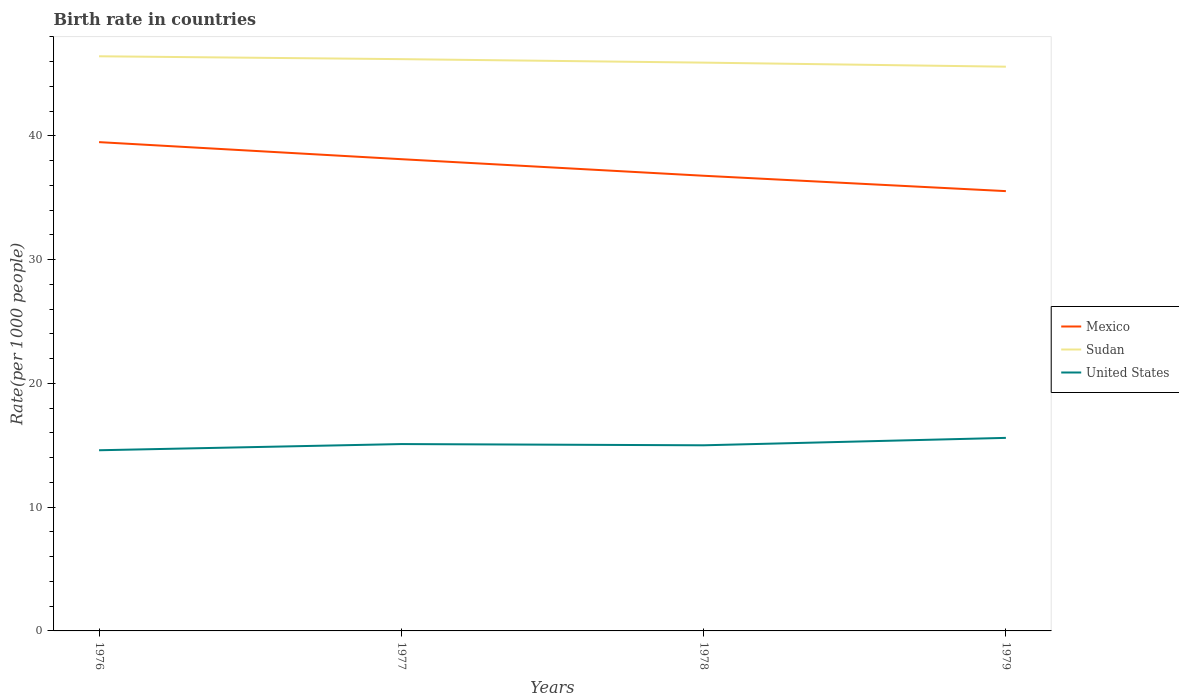In which year was the birth rate in Mexico maximum?
Offer a terse response. 1979. What is the difference between the highest and the second highest birth rate in Sudan?
Your response must be concise. 0.84. How many lines are there?
Provide a succinct answer. 3. How many years are there in the graph?
Offer a very short reply. 4. What is the difference between two consecutive major ticks on the Y-axis?
Offer a terse response. 10. Does the graph contain any zero values?
Offer a terse response. No. Where does the legend appear in the graph?
Keep it short and to the point. Center right. How are the legend labels stacked?
Provide a succinct answer. Vertical. What is the title of the graph?
Your answer should be very brief. Birth rate in countries. What is the label or title of the Y-axis?
Offer a very short reply. Rate(per 1000 people). What is the Rate(per 1000 people) in Mexico in 1976?
Keep it short and to the point. 39.5. What is the Rate(per 1000 people) in Sudan in 1976?
Your answer should be compact. 46.44. What is the Rate(per 1000 people) in United States in 1976?
Offer a very short reply. 14.6. What is the Rate(per 1000 people) of Mexico in 1977?
Offer a terse response. 38.12. What is the Rate(per 1000 people) in Sudan in 1977?
Ensure brevity in your answer.  46.2. What is the Rate(per 1000 people) in United States in 1977?
Your response must be concise. 15.1. What is the Rate(per 1000 people) of Mexico in 1978?
Provide a short and direct response. 36.78. What is the Rate(per 1000 people) of Sudan in 1978?
Provide a short and direct response. 45.92. What is the Rate(per 1000 people) in United States in 1978?
Provide a succinct answer. 15. What is the Rate(per 1000 people) in Mexico in 1979?
Offer a very short reply. 35.54. What is the Rate(per 1000 people) of Sudan in 1979?
Offer a very short reply. 45.6. Across all years, what is the maximum Rate(per 1000 people) of Mexico?
Provide a succinct answer. 39.5. Across all years, what is the maximum Rate(per 1000 people) of Sudan?
Your response must be concise. 46.44. Across all years, what is the maximum Rate(per 1000 people) of United States?
Provide a short and direct response. 15.6. Across all years, what is the minimum Rate(per 1000 people) of Mexico?
Ensure brevity in your answer.  35.54. Across all years, what is the minimum Rate(per 1000 people) of Sudan?
Provide a short and direct response. 45.6. Across all years, what is the minimum Rate(per 1000 people) of United States?
Your answer should be compact. 14.6. What is the total Rate(per 1000 people) of Mexico in the graph?
Your response must be concise. 149.94. What is the total Rate(per 1000 people) in Sudan in the graph?
Your answer should be very brief. 184.16. What is the total Rate(per 1000 people) of United States in the graph?
Ensure brevity in your answer.  60.3. What is the difference between the Rate(per 1000 people) in Mexico in 1976 and that in 1977?
Provide a short and direct response. 1.38. What is the difference between the Rate(per 1000 people) in Sudan in 1976 and that in 1977?
Keep it short and to the point. 0.23. What is the difference between the Rate(per 1000 people) in United States in 1976 and that in 1977?
Offer a terse response. -0.5. What is the difference between the Rate(per 1000 people) in Mexico in 1976 and that in 1978?
Provide a succinct answer. 2.72. What is the difference between the Rate(per 1000 people) in Sudan in 1976 and that in 1978?
Keep it short and to the point. 0.51. What is the difference between the Rate(per 1000 people) of Mexico in 1976 and that in 1979?
Your answer should be very brief. 3.96. What is the difference between the Rate(per 1000 people) in Sudan in 1976 and that in 1979?
Your answer should be very brief. 0.84. What is the difference between the Rate(per 1000 people) of Mexico in 1977 and that in 1978?
Offer a very short reply. 1.34. What is the difference between the Rate(per 1000 people) of Sudan in 1977 and that in 1978?
Provide a short and direct response. 0.28. What is the difference between the Rate(per 1000 people) in United States in 1977 and that in 1978?
Make the answer very short. 0.1. What is the difference between the Rate(per 1000 people) of Mexico in 1977 and that in 1979?
Make the answer very short. 2.58. What is the difference between the Rate(per 1000 people) in Sudan in 1977 and that in 1979?
Your response must be concise. 0.61. What is the difference between the Rate(per 1000 people) in Mexico in 1978 and that in 1979?
Ensure brevity in your answer.  1.24. What is the difference between the Rate(per 1000 people) in Sudan in 1978 and that in 1979?
Make the answer very short. 0.33. What is the difference between the Rate(per 1000 people) of United States in 1978 and that in 1979?
Make the answer very short. -0.6. What is the difference between the Rate(per 1000 people) in Mexico in 1976 and the Rate(per 1000 people) in Sudan in 1977?
Your answer should be very brief. -6.71. What is the difference between the Rate(per 1000 people) in Mexico in 1976 and the Rate(per 1000 people) in United States in 1977?
Your response must be concise. 24.4. What is the difference between the Rate(per 1000 people) in Sudan in 1976 and the Rate(per 1000 people) in United States in 1977?
Make the answer very short. 31.34. What is the difference between the Rate(per 1000 people) in Mexico in 1976 and the Rate(per 1000 people) in Sudan in 1978?
Keep it short and to the point. -6.42. What is the difference between the Rate(per 1000 people) of Mexico in 1976 and the Rate(per 1000 people) of United States in 1978?
Provide a short and direct response. 24.5. What is the difference between the Rate(per 1000 people) in Sudan in 1976 and the Rate(per 1000 people) in United States in 1978?
Provide a short and direct response. 31.44. What is the difference between the Rate(per 1000 people) of Mexico in 1976 and the Rate(per 1000 people) of Sudan in 1979?
Make the answer very short. -6.1. What is the difference between the Rate(per 1000 people) of Mexico in 1976 and the Rate(per 1000 people) of United States in 1979?
Your answer should be very brief. 23.9. What is the difference between the Rate(per 1000 people) of Sudan in 1976 and the Rate(per 1000 people) of United States in 1979?
Ensure brevity in your answer.  30.84. What is the difference between the Rate(per 1000 people) in Mexico in 1977 and the Rate(per 1000 people) in Sudan in 1978?
Your answer should be very brief. -7.8. What is the difference between the Rate(per 1000 people) in Mexico in 1977 and the Rate(per 1000 people) in United States in 1978?
Give a very brief answer. 23.12. What is the difference between the Rate(per 1000 people) of Sudan in 1977 and the Rate(per 1000 people) of United States in 1978?
Offer a terse response. 31.2. What is the difference between the Rate(per 1000 people) in Mexico in 1977 and the Rate(per 1000 people) in Sudan in 1979?
Give a very brief answer. -7.47. What is the difference between the Rate(per 1000 people) of Mexico in 1977 and the Rate(per 1000 people) of United States in 1979?
Ensure brevity in your answer.  22.52. What is the difference between the Rate(per 1000 people) of Sudan in 1977 and the Rate(per 1000 people) of United States in 1979?
Offer a very short reply. 30.61. What is the difference between the Rate(per 1000 people) of Mexico in 1978 and the Rate(per 1000 people) of Sudan in 1979?
Provide a short and direct response. -8.81. What is the difference between the Rate(per 1000 people) of Mexico in 1978 and the Rate(per 1000 people) of United States in 1979?
Provide a succinct answer. 21.18. What is the difference between the Rate(per 1000 people) of Sudan in 1978 and the Rate(per 1000 people) of United States in 1979?
Your answer should be very brief. 30.32. What is the average Rate(per 1000 people) in Mexico per year?
Ensure brevity in your answer.  37.49. What is the average Rate(per 1000 people) of Sudan per year?
Your response must be concise. 46.04. What is the average Rate(per 1000 people) of United States per year?
Give a very brief answer. 15.07. In the year 1976, what is the difference between the Rate(per 1000 people) of Mexico and Rate(per 1000 people) of Sudan?
Ensure brevity in your answer.  -6.94. In the year 1976, what is the difference between the Rate(per 1000 people) in Mexico and Rate(per 1000 people) in United States?
Make the answer very short. 24.9. In the year 1976, what is the difference between the Rate(per 1000 people) in Sudan and Rate(per 1000 people) in United States?
Your answer should be very brief. 31.84. In the year 1977, what is the difference between the Rate(per 1000 people) of Mexico and Rate(per 1000 people) of Sudan?
Your response must be concise. -8.08. In the year 1977, what is the difference between the Rate(per 1000 people) in Mexico and Rate(per 1000 people) in United States?
Provide a short and direct response. 23.02. In the year 1977, what is the difference between the Rate(per 1000 people) of Sudan and Rate(per 1000 people) of United States?
Offer a very short reply. 31.11. In the year 1978, what is the difference between the Rate(per 1000 people) in Mexico and Rate(per 1000 people) in Sudan?
Provide a succinct answer. -9.14. In the year 1978, what is the difference between the Rate(per 1000 people) of Mexico and Rate(per 1000 people) of United States?
Your answer should be compact. 21.78. In the year 1978, what is the difference between the Rate(per 1000 people) of Sudan and Rate(per 1000 people) of United States?
Keep it short and to the point. 30.92. In the year 1979, what is the difference between the Rate(per 1000 people) in Mexico and Rate(per 1000 people) in Sudan?
Give a very brief answer. -10.06. In the year 1979, what is the difference between the Rate(per 1000 people) of Mexico and Rate(per 1000 people) of United States?
Keep it short and to the point. 19.94. In the year 1979, what is the difference between the Rate(per 1000 people) of Sudan and Rate(per 1000 people) of United States?
Offer a terse response. 30. What is the ratio of the Rate(per 1000 people) of Mexico in 1976 to that in 1977?
Keep it short and to the point. 1.04. What is the ratio of the Rate(per 1000 people) of United States in 1976 to that in 1977?
Give a very brief answer. 0.97. What is the ratio of the Rate(per 1000 people) of Mexico in 1976 to that in 1978?
Provide a short and direct response. 1.07. What is the ratio of the Rate(per 1000 people) of Sudan in 1976 to that in 1978?
Offer a very short reply. 1.01. What is the ratio of the Rate(per 1000 people) of United States in 1976 to that in 1978?
Provide a short and direct response. 0.97. What is the ratio of the Rate(per 1000 people) in Mexico in 1976 to that in 1979?
Keep it short and to the point. 1.11. What is the ratio of the Rate(per 1000 people) in Sudan in 1976 to that in 1979?
Provide a succinct answer. 1.02. What is the ratio of the Rate(per 1000 people) of United States in 1976 to that in 1979?
Give a very brief answer. 0.94. What is the ratio of the Rate(per 1000 people) of Mexico in 1977 to that in 1978?
Offer a very short reply. 1.04. What is the ratio of the Rate(per 1000 people) of Mexico in 1977 to that in 1979?
Offer a terse response. 1.07. What is the ratio of the Rate(per 1000 people) of Sudan in 1977 to that in 1979?
Make the answer very short. 1.01. What is the ratio of the Rate(per 1000 people) of United States in 1977 to that in 1979?
Provide a short and direct response. 0.97. What is the ratio of the Rate(per 1000 people) in Mexico in 1978 to that in 1979?
Offer a very short reply. 1.03. What is the ratio of the Rate(per 1000 people) of Sudan in 1978 to that in 1979?
Provide a succinct answer. 1.01. What is the ratio of the Rate(per 1000 people) in United States in 1978 to that in 1979?
Your answer should be very brief. 0.96. What is the difference between the highest and the second highest Rate(per 1000 people) in Mexico?
Your response must be concise. 1.38. What is the difference between the highest and the second highest Rate(per 1000 people) in Sudan?
Offer a terse response. 0.23. What is the difference between the highest and the lowest Rate(per 1000 people) in Mexico?
Give a very brief answer. 3.96. What is the difference between the highest and the lowest Rate(per 1000 people) in Sudan?
Provide a short and direct response. 0.84. 